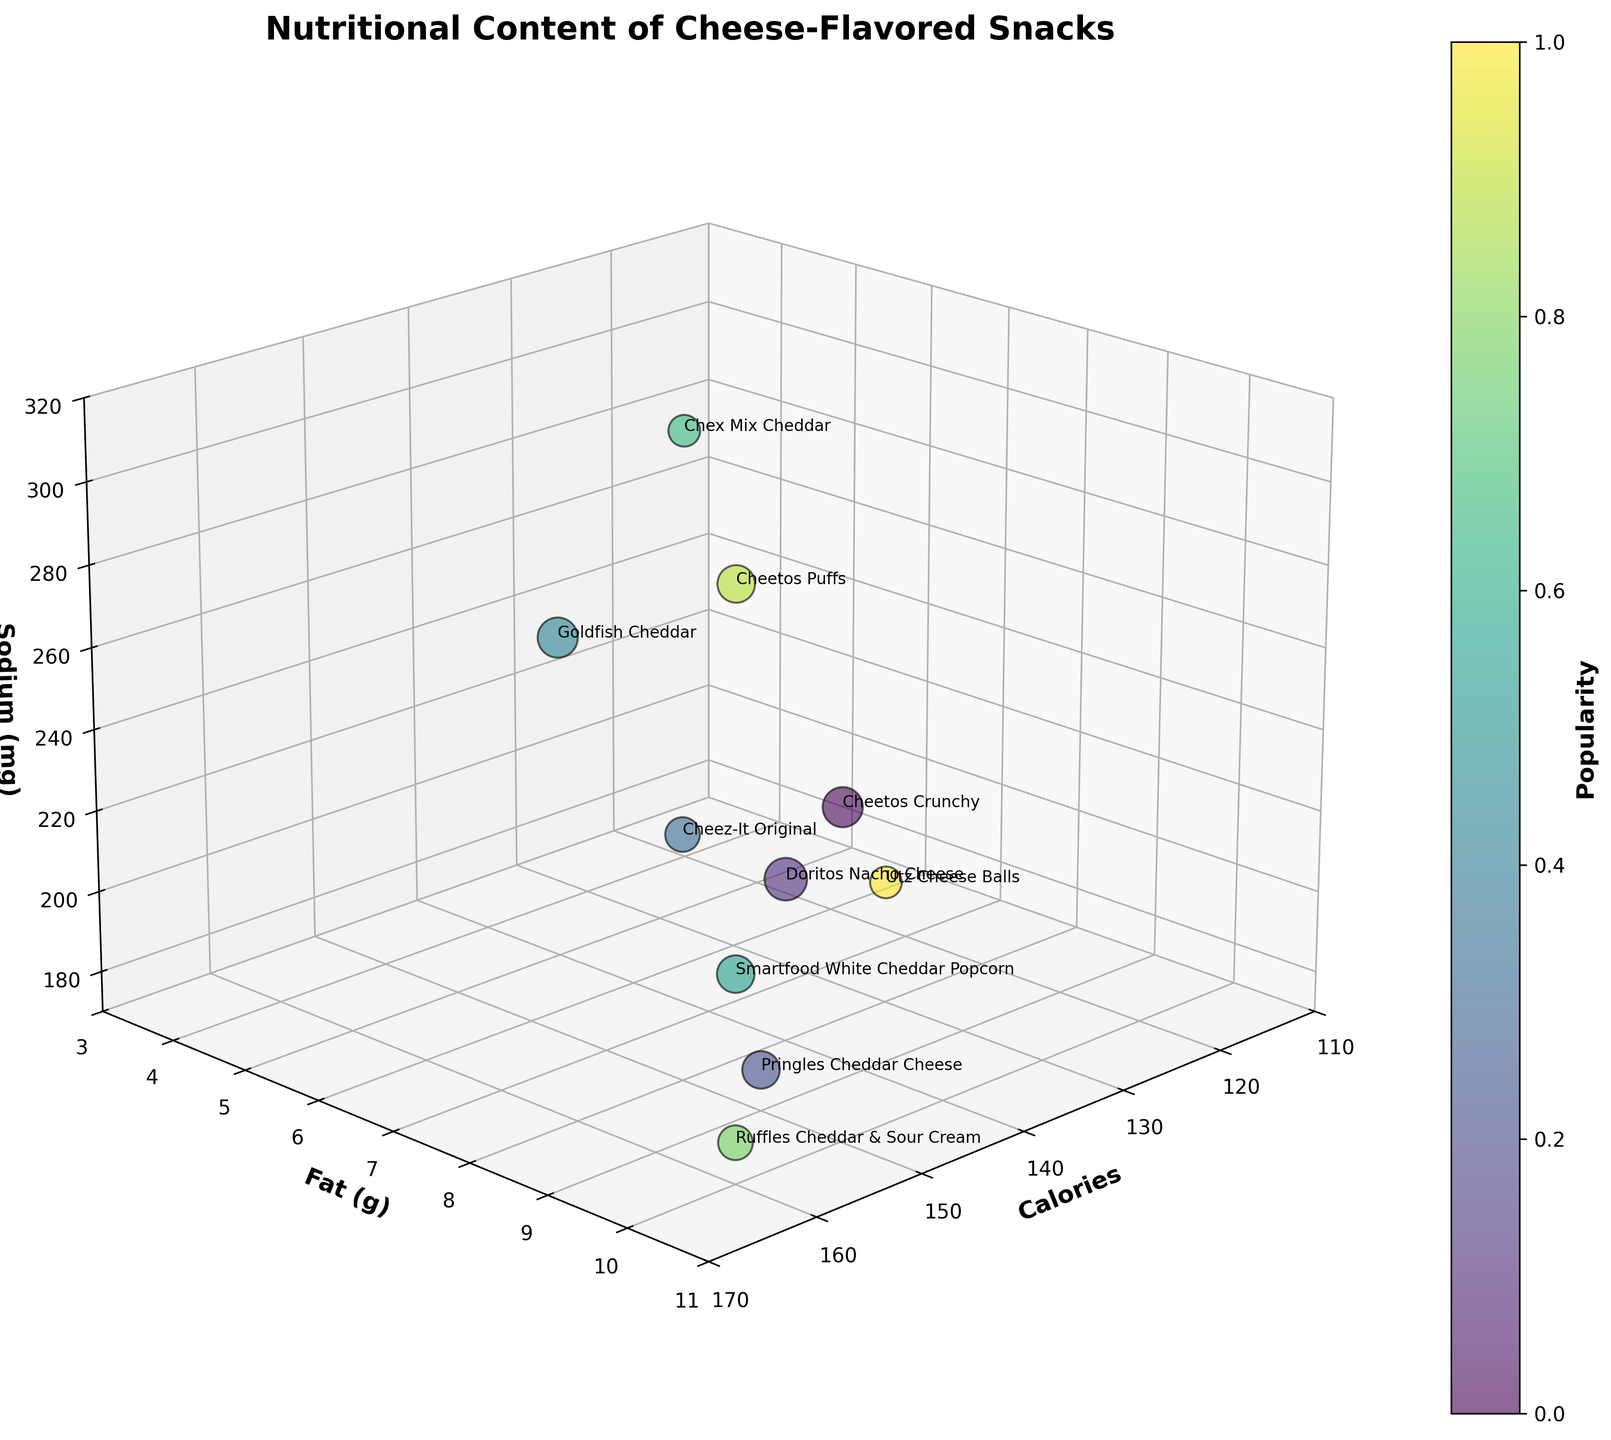What is the title of the 3D bubble chart? The title is prominently displayed at the top of the chart. It indicates the main topic or the subject matter of the visualization.
Answer: "Nutritional Content of Cheese-Flavored Snacks" Which cheese-flavored snack has the highest sodium content? By looking at the 'Sodium (mg)' axis, we identify the highest point and check the corresponding snack label.
Answer: Cheetos Puffs How many snacks have a popularity score of 7? Popularity is indicated by the size of the bubbles. Observing the chart, we count the number of bubbles of the same size that corresponds to a popularity score of 7.
Answer: 3 Which snack has the most balanced levels of calories, fat, and sodium? A balanced snack would be located near the median of all three axes. By visually inspecting the central point of the axes (Calories, Fat, Sodium), we can determine the closest snack.
Answer: Cheez-It Original Which snack has the highest fat content but the lowest calories? By observing the 'Fat (g)' axis for the highest value and then checking the corresponding 'Calories' value to find the lowest one, we identify the snack.
Answer: Smartfood White Cheddar Popcorn Compare the sodium content of Cheez-It Original and Pringles Cheddar Cheese. Which one is higher? By locating the positions of both Cheez-It Original and Pringles Cheddar Cheese on the 'Sodium (mg)' axis, we can compare their respective values.
Answer: Cheez-It Original What is the average calories content of all the snacks? Sum up all the calories and divide by the number of snacks: (150+140+150+150+140+160+120+160+160+130)/10.
Answer: 146 Which snack is the least popular, and what are its nutritional details? The least popular snack is indicated by the smallest bubble size. We then check the nutritional values of that corresponding bubble.
Answer: Chex Mix Cheddar: 120 calories, 4g fat, and 280 mg sodium How do Goldfish Cheddar snacks compare to Doritos Nacho Cheese in terms of calories and fat content? We compare the position of both snacks on the 'Calories' and 'Fat (g)' axes. Goldfish Cheddar has 140 calories and 5g of fat, whereas Doritos Nacho Cheese has 140 calories and 8g of fat.
Answer: Both have 140 calories, but Goldfish Cheddar has 3g less fat Out of the snacks with 10g of fat, which one has the lowest sodium content? By filtering for the snacks with 10g of fat, we compare their positions on the 'Sodium (mg)' axis to identify the lowest sodium content.
Answer: Ruffles Cheddar & Sour Cream 